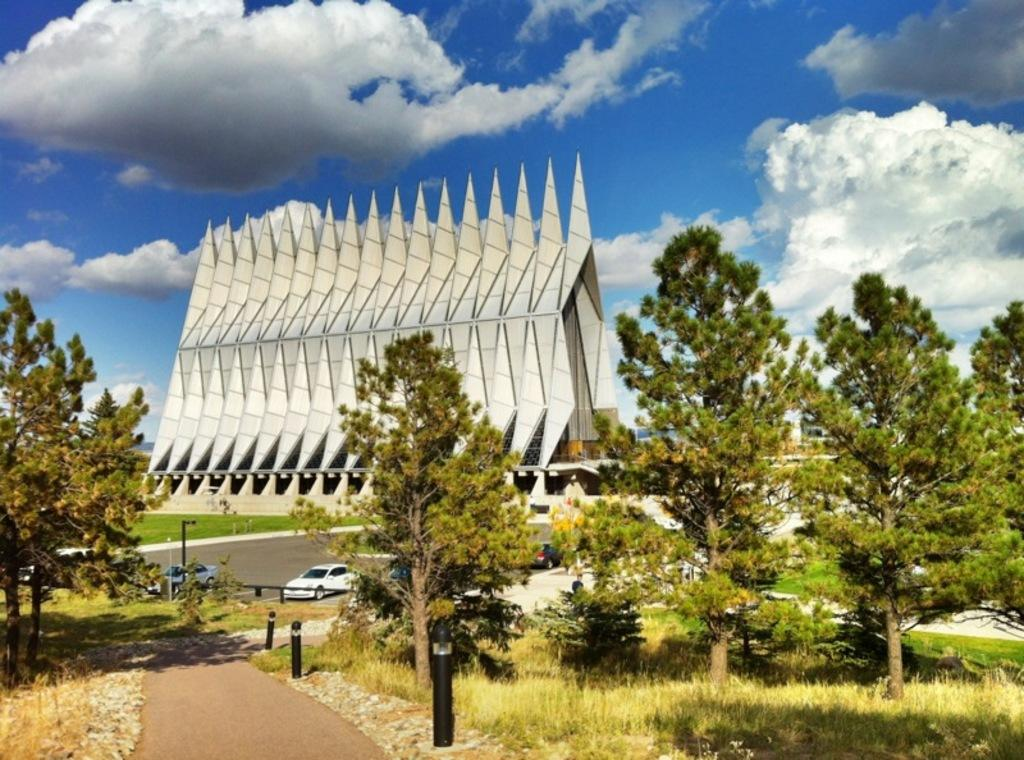What type of vegetation is present in the image? There are trees in the image. What color are the trees? The trees are green. What can be seen in the background of the image? There are vehicles and light poles in the background of the image. What is the color of the building in the image? The building in the image is white. What is the color of the sky in the image? The sky is blue and white. Where are the books located in the image? There are no books present in the image. Can you see a horse in the image? There is no horse present in the image. 